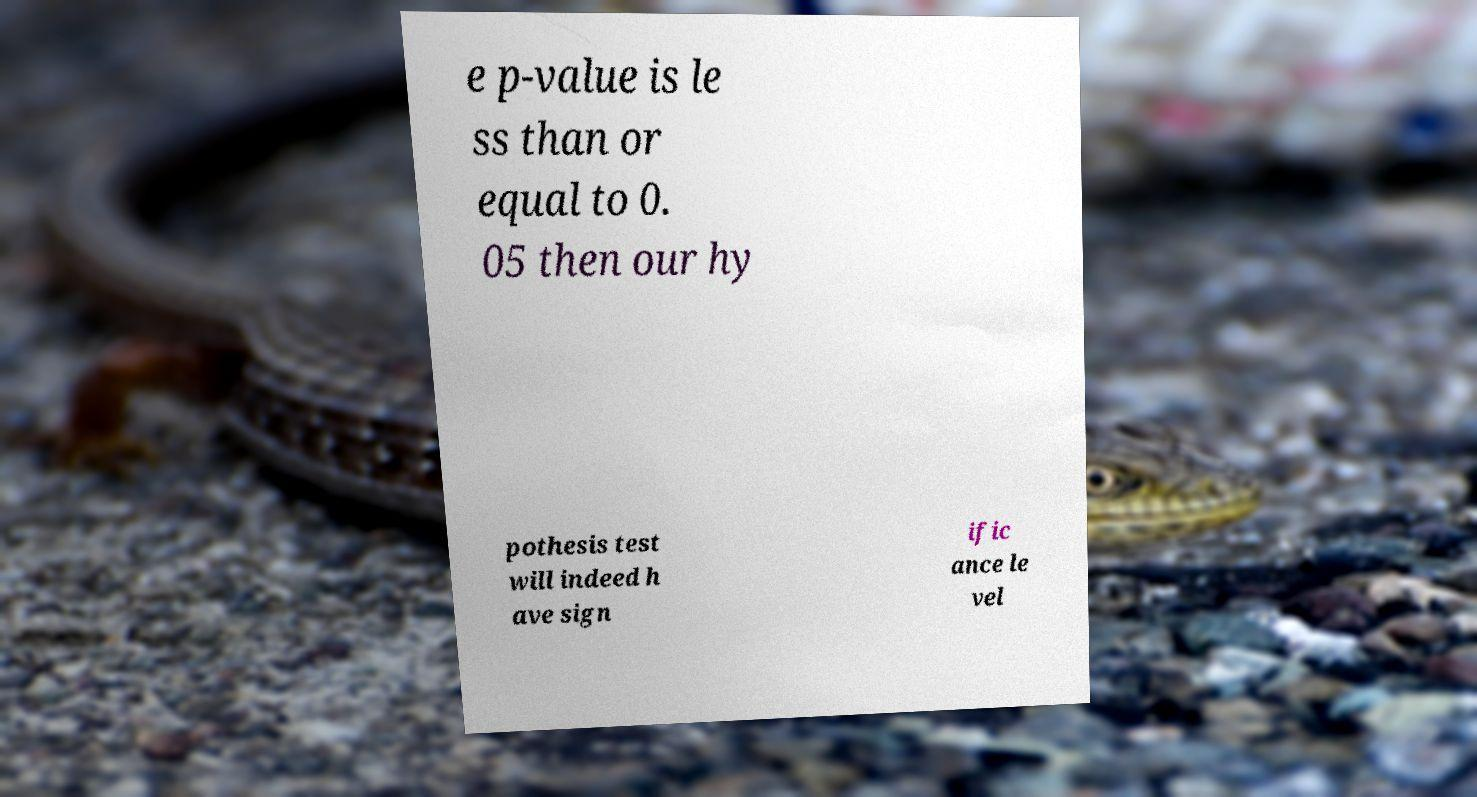Please read and relay the text visible in this image. What does it say? e p-value is le ss than or equal to 0. 05 then our hy pothesis test will indeed h ave sign ific ance le vel 